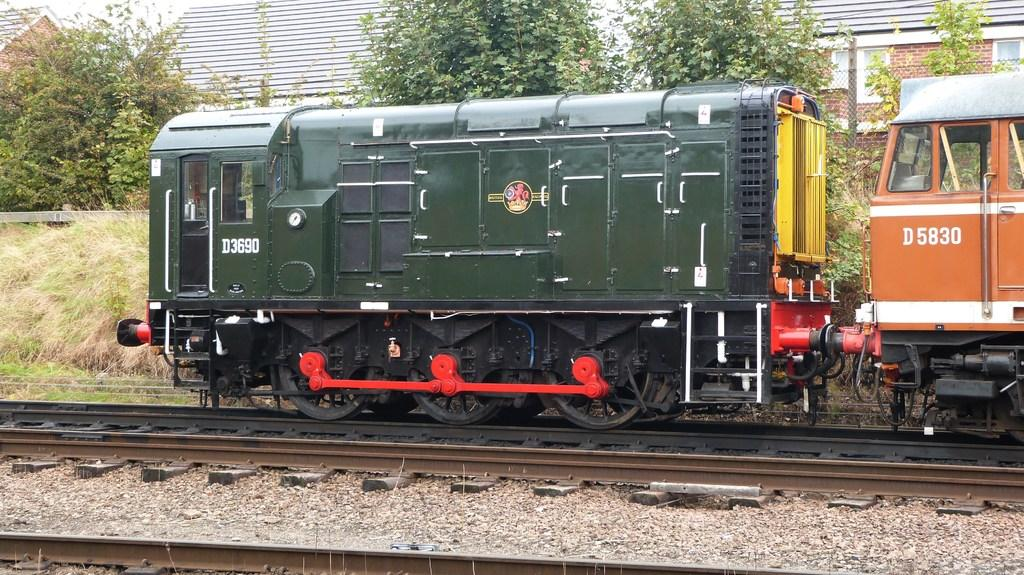<image>
Share a concise interpretation of the image provided. A green train engine D3690 is pulling the orange train engine D5830. 